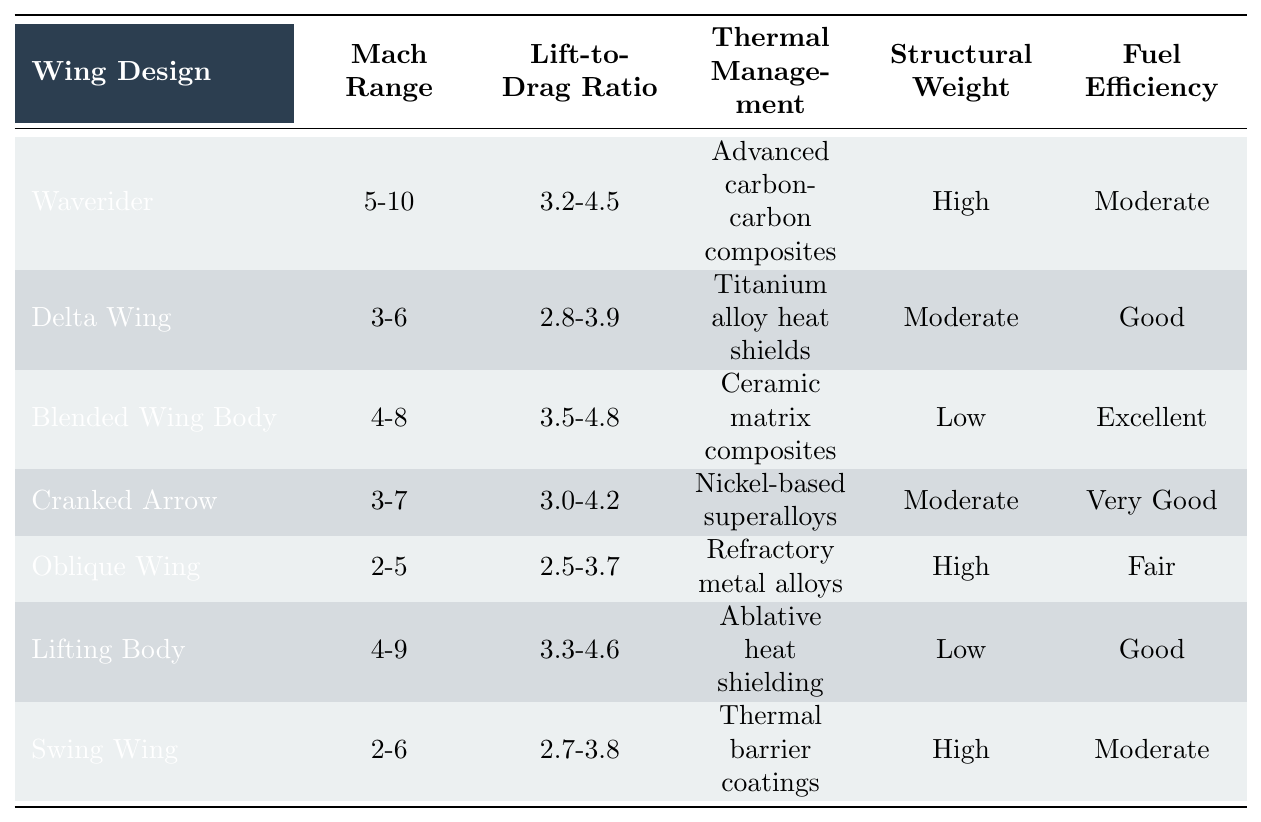What is the Mach range of the Blended Wing Body design? The table shows that the Mach range for the Blended Wing Body is listed directly under the "Mach Range" column. Referring to that entry, it can be found to be 4-8.
Answer: 4-8 Which wing design has the highest Lift-to-Drag ratio? In the "Lift-to-Drag Ratio" column, the highest value is found for the Blended Wing Body design, which has a Lift-to-Drag ratio of 3.5-4.8.
Answer: Blended Wing Body Is the fuel efficiency of the Waverider design classified as "Excellent"? In the "Fuel Efficiency" column for the Waverider design, it is stated as "Moderate." Therefore, the statement is false.
Answer: No Which wing design has the lowest structural weight? The table indicates that both the Blended Wing Body and Lifting Body designs have "Low" structural weight, but since the question asks for the wing design, the answer would be Blended Wing Body.
Answer: Blended Wing Body What is the average Lift-to-Drag Ratio of the Delta Wing and Cranked Arrow designs? The Lift-to-Drag Ratio for the Delta Wing is 2.8-3.9, which averages to (2.8 + 3.9) / 2 = 3.35; for Cranked Arrow, the ratio is 3.0-4.2, which averages to (3.0 + 4.2) / 2 = 3.6. To find the overall average: (3.35 + 3.6) / 2 = 3.475.
Answer: 3.475 Which wing design has both high structural weight and high thermal management? Upon reviewing the table, the Waverider and Swing Wing designs are noted for having high structural weight and also high thermal management. However, since we need a single design, we could choose the Waverider, as it fits this criterion.
Answer: Waverider How many wing designs have a Mach range below 5? By inspecting the "Mach Range" column, we note that Oblique Wing and Swing Wing are the designs below Mach 5, making it a total of 3 distinct designs fitting this criterion (Oblique Wing, Swing Wing, and Waverider).
Answer: 3 What is the difference in thermal management characteristics between the Blended Wing Body and the Waverider? For Blended Wing Body, the thermal management is labeled "Low," while for Waverider, it states "Advanced carbon-carbon composites." Thus, the difference is that the Waverider has advanced materials for thermal management, while the Blended Wing Body utilizes less sophisticated methods.
Answer: Waverider has advanced, Blended Wing Body has low 